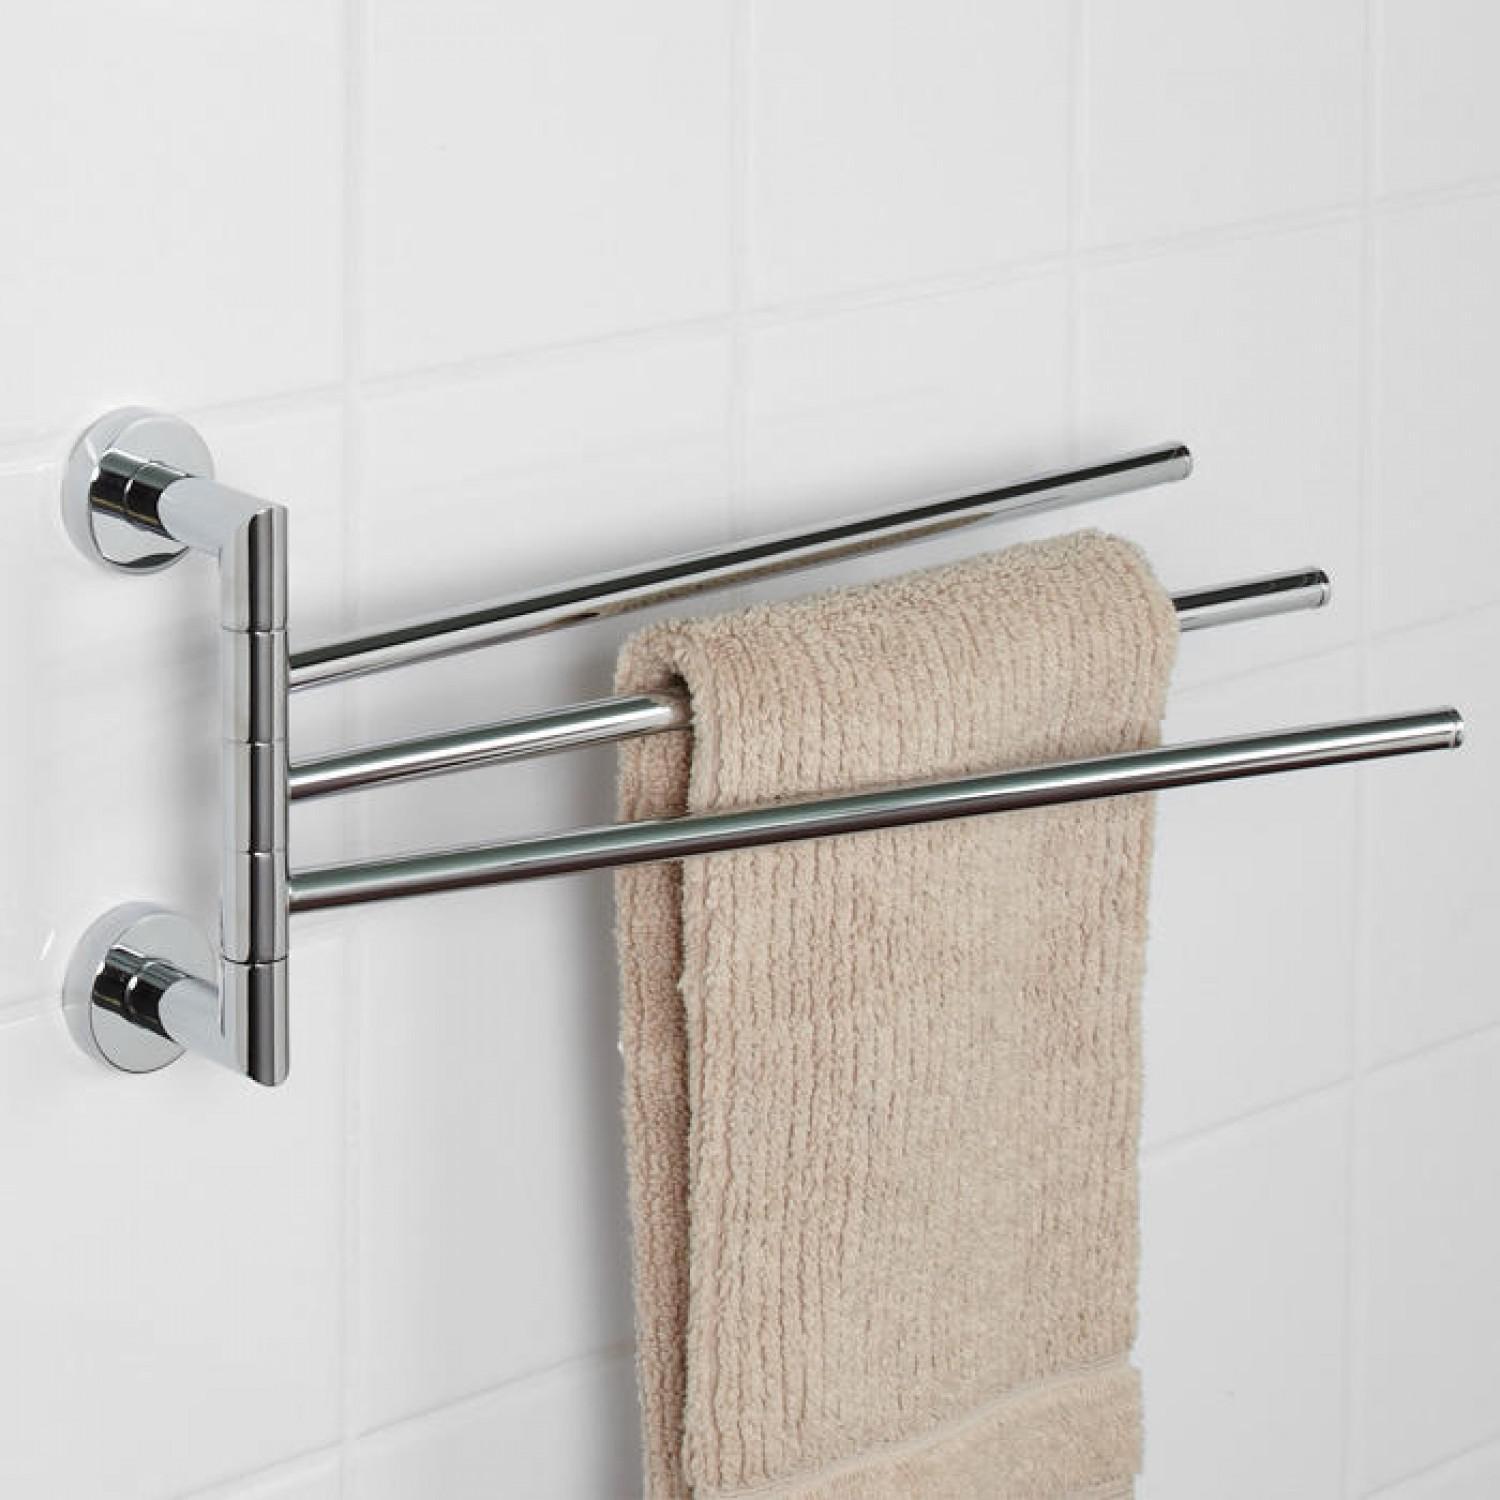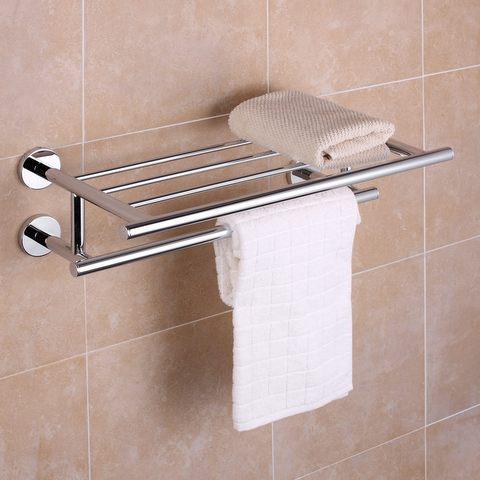The first image is the image on the left, the second image is the image on the right. Considering the images on both sides, is "One of the racks has nothing on it." valid? Answer yes or no. No. 